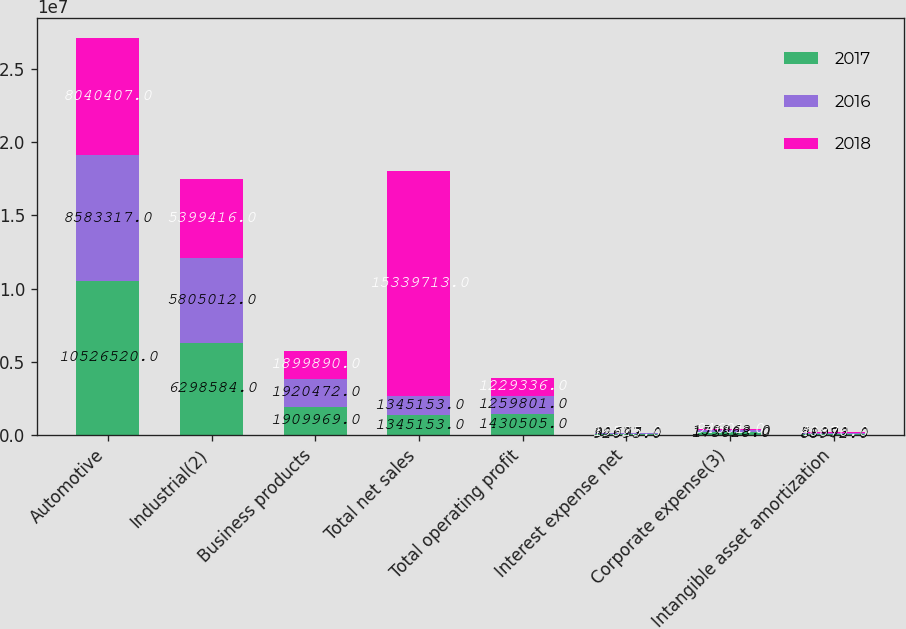Convert chart to OTSL. <chart><loc_0><loc_0><loc_500><loc_500><stacked_bar_chart><ecel><fcel>Automotive<fcel>Industrial(2)<fcel>Business products<fcel>Total net sales<fcel>Total operating profit<fcel>Interest expense net<fcel>Corporate expense(3)<fcel>Intangible asset amortization<nl><fcel>2017<fcel>1.05265e+07<fcel>6.29858e+06<fcel>1.90997e+06<fcel>1.34515e+06<fcel>1.4305e+06<fcel>92093<fcel>173828<fcel>88972<nl><fcel>2016<fcel>8.58332e+06<fcel>5.80501e+06<fcel>1.92047e+06<fcel>1.34515e+06<fcel>1.2598e+06<fcel>38677<fcel>159863<fcel>51993<nl><fcel>2018<fcel>8.04041e+06<fcel>5.39942e+06<fcel>1.89989e+06<fcel>1.53397e+07<fcel>1.22934e+06<fcel>19525<fcel>94601<fcel>40870<nl></chart> 